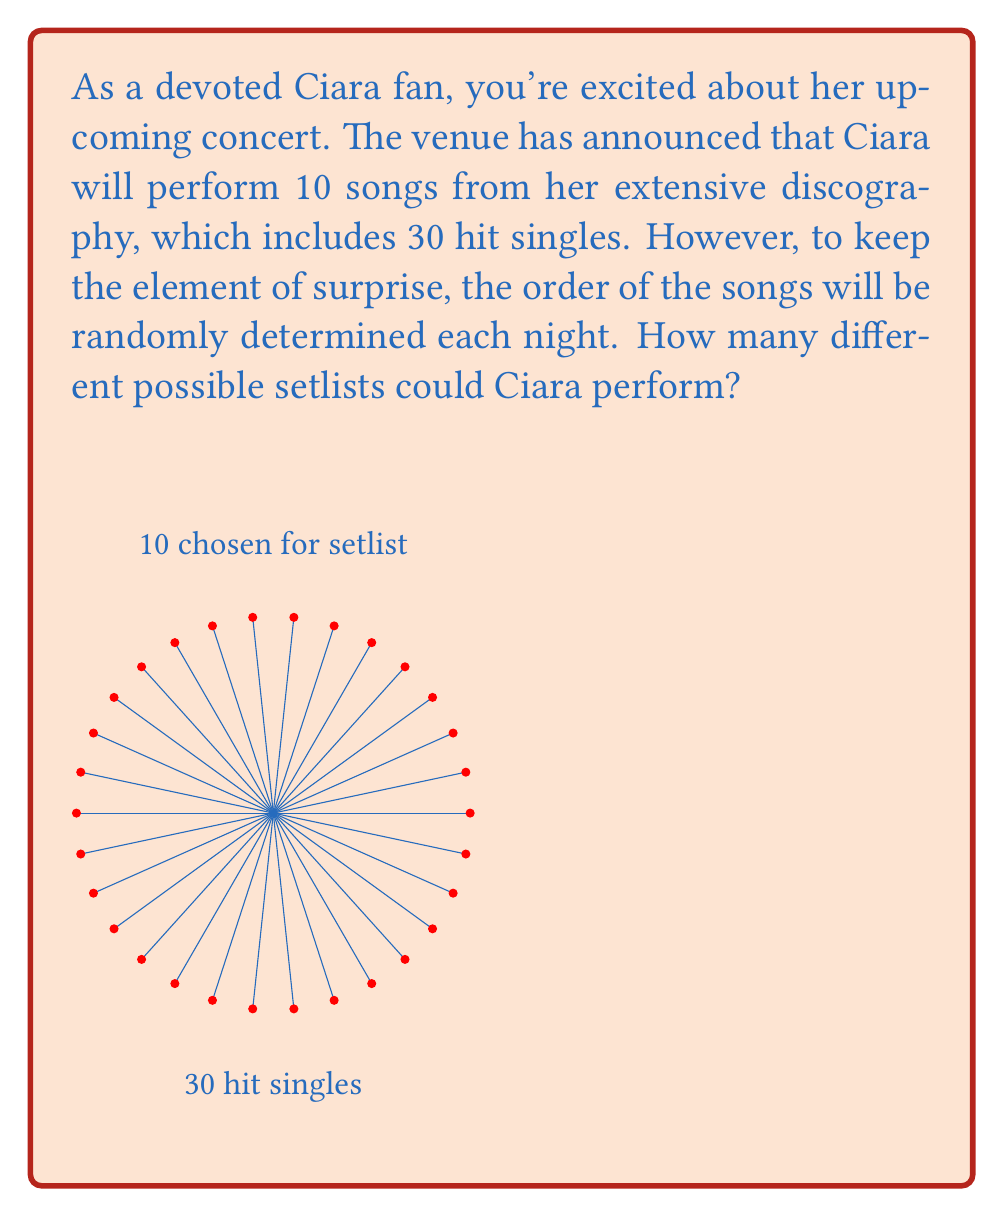What is the answer to this math problem? Let's approach this step-by-step:

1) This is a permutation problem. We are selecting 10 songs out of 30 and the order matters.

2) For the first song, Ciara has 30 choices.

3) For the second song, she has 29 choices remaining, as one song has already been performed.

4) This pattern continues for all 10 songs in the setlist.

5) We can represent this mathematically as:

   $30 \times 29 \times 28 \times 27 \times 26 \times 25 \times 24 \times 23 \times 22 \times 21$

6) This is equivalent to the permutation formula:

   $$P(30,10) = \frac{30!}{(30-10)!} = \frac{30!}{20!}$$

7) Calculating this:
   
   $$\frac{30!}{20!} = 30 \times 29 \times 28 \times 27 \times 26 \times 25 \times 24 \times 23 \times 22 \times 21$$
   
   $$= 726,485,760,000$$

Therefore, there are 726,485,760,000 different possible setlists Ciara could perform.
Answer: 726,485,760,000 